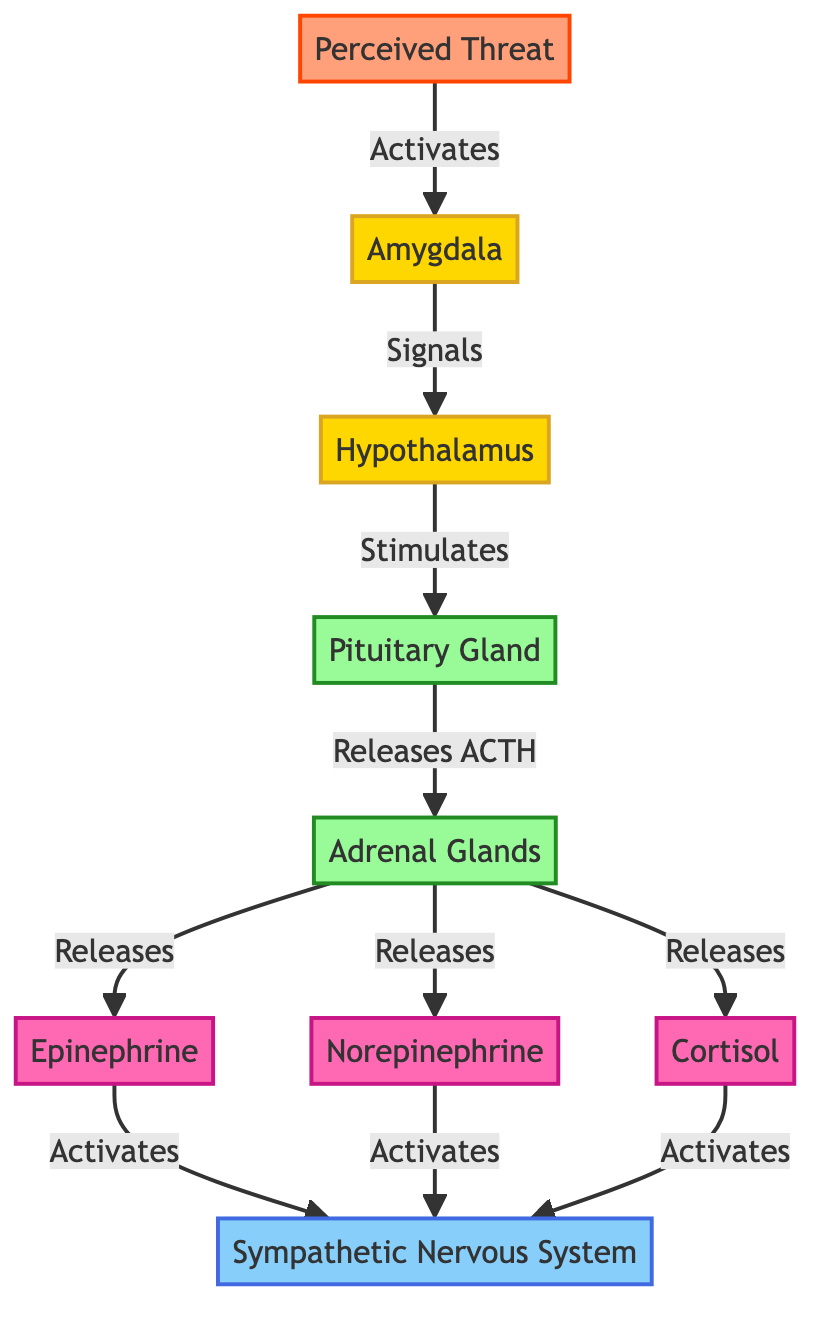What is the first node activated during the fight-or-flight response? The first node indicated in the diagram is the Perceived Threat, which activates the amygdala. Thus, the sequence begins with perceiving a threat as the triggering event.
Answer: Perceived Threat How many hormones are released by the adrenal glands? The diagram shows three hormones released by the adrenal glands: Epinephrine, Norepinephrine, and Cortisol. Therefore, the total count is three hormones.
Answer: Three Which brain region signals the hypothalamus? According to the diagram, the amygdala signals the hypothalamus in response to a perceived threat. This direct connection indicates the amygdala's role in processing fear and stress signals.
Answer: Amygdala What does the hypothalamus stimulate? The hypothalamus stimulates the pituitary gland as shown in the diagram, leading to the release of adrenocorticotropic hormone (ACTH), which further acts on adrenal glands.
Answer: Pituitary Gland What is the relationship between epinephrine and the sympathetic nervous system? The diagram illustrates that epinephrine activates the sympathetic nervous system, playing a crucial role in the body’s fight-or-flight response. This indicates that the release of this hormone prepares the body for rapid action.
Answer: Activates How does the pituitary gland contribute to the activation of the adrenal glands? The pituitary gland releases ACTH, which in turn stimulates the adrenal glands to release hormones like epinephrine, norepinephrine, and cortisol. This connection illustrates a key step in the hormonal cascade during stress responses.
Answer: Releases ACTH What structure is responsible for perceiving threats? The diagram labels the Perceived Threat node, indicating that it is the key structure for recognizing alarming stimuli in the environment which triggers a stress response.
Answer: Amygdala Which neurotransmitter is associated with the adrenal glands? The diagram specifies both epinephrine and norepinephrine as the hormones released by the adrenal glands, making them direct associations with this anatomical structure during the stress response.
Answer: Epinephrine, Norepinephrine Which system gets activated by cortisol? The sympathetic nervous system is activated by cortisol, as depicted in the diagram. This highlights the hormone’s role in sustaining the fight-or-flight response beyond immediate reactions.
Answer: Sympathetic Nervous System 